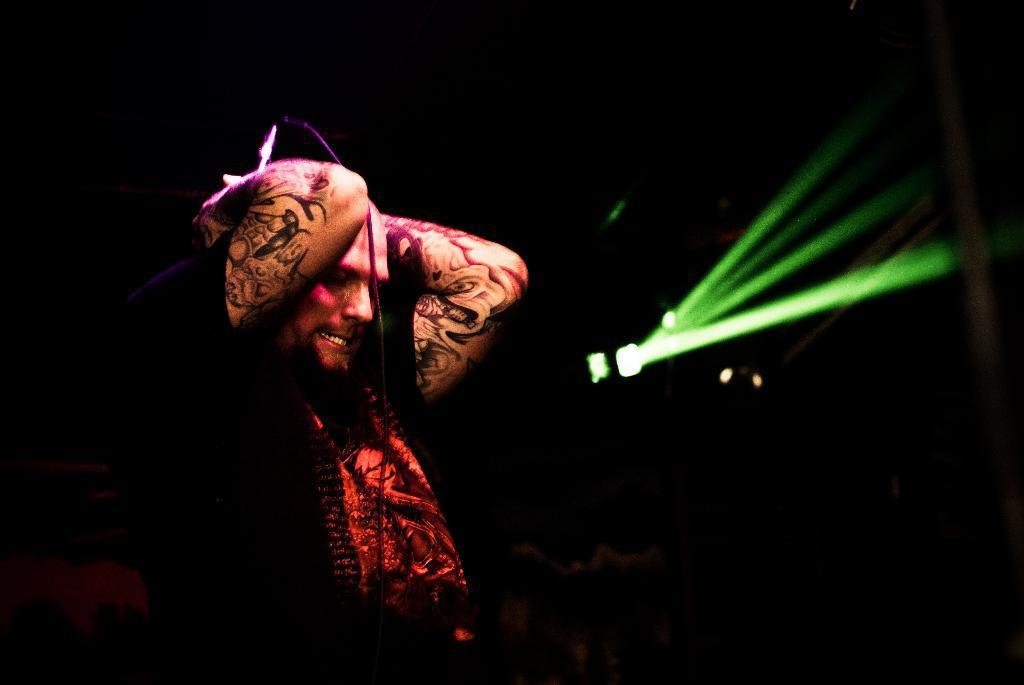Describe this image in one or two sentences. In this picture we can see a man is holding a microphone, on the right side there is a light, we can see a dark background. 